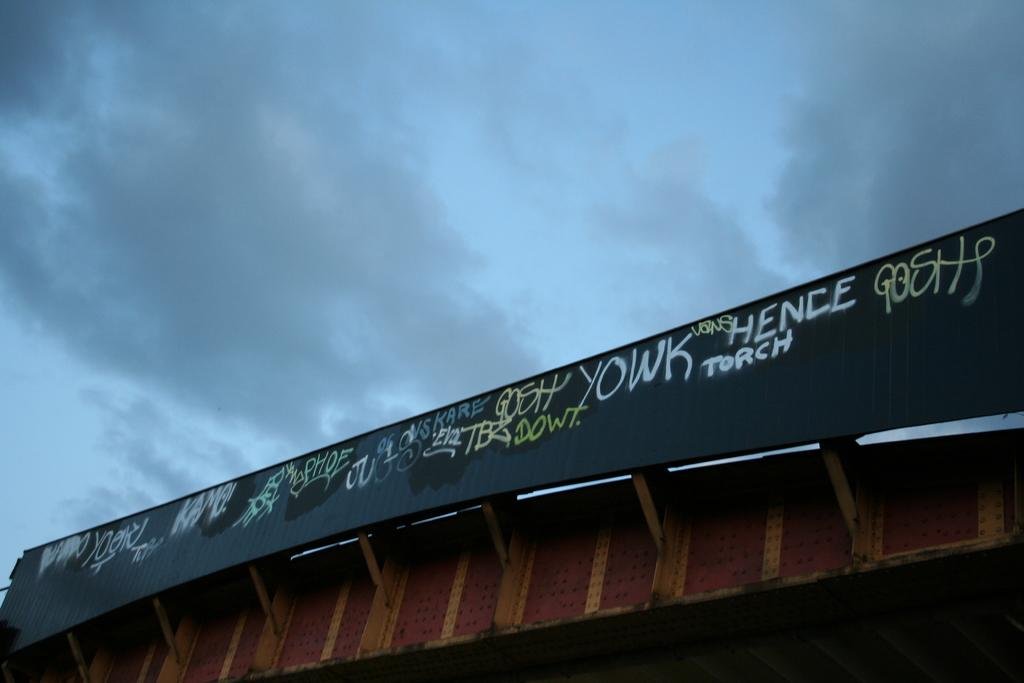<image>
Relay a brief, clear account of the picture shown. the word hence is on a bridge located outside 